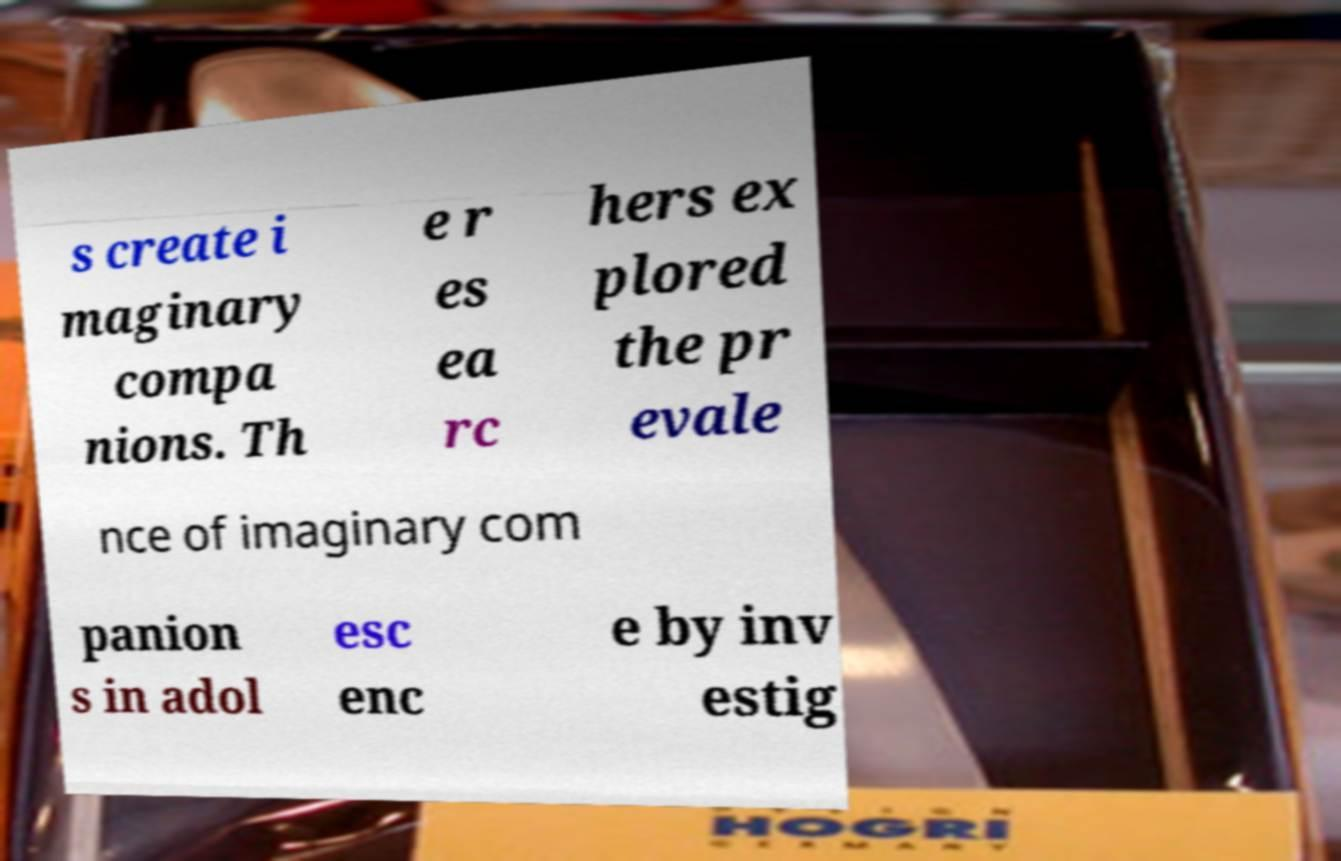Please read and relay the text visible in this image. What does it say? s create i maginary compa nions. Th e r es ea rc hers ex plored the pr evale nce of imaginary com panion s in adol esc enc e by inv estig 